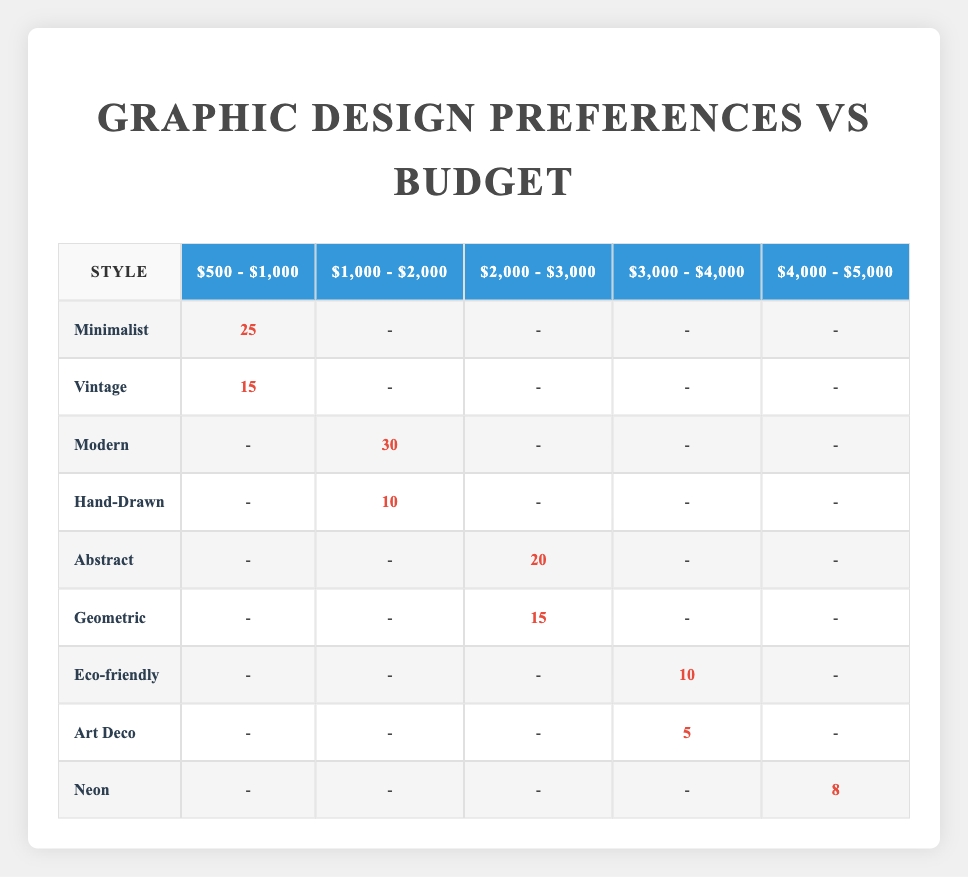What is the client count for the Minimalist style within the budget range of $500 - $1,000? The table lists the client count for the Minimalist style under the budget range of $500 - $1,000 as 25.
Answer: 25 How many clients prefer the Vintage style within the same budget range of $500 - $1,000? The table indicates that the client count for the Vintage style within the $500 - $1,000 budget range is 15.
Answer: 15 Which graphic design style has the highest number of clients within the budget range of $1,000 - $2,000? The Modern style has the highest client count of 30 within the $1,000 - $2,000 budget range.
Answer: Modern What is the total number of clients interested in budget ranges between $2,000 to $4,000? Summing the client counts from $2,000 - $3,000 (20 + 15) and $3,000 - $4,000 (10 + 5) gives a total of 50 clients.
Answer: 50 Is there any graphic design style that clients prefer in the budget range of $4,000 - $5,000? The only style listed in the budget range of $4,000 - $5,000 is Neon, with 8 clients preferring it, which confirms that there is a preference.
Answer: Yes What is the average client count for styles in the budget range of $1,000 - $2,000? There are two styles: Modern (30) and Hand-Drawn (10). The average is (30 + 10) / 2 = 20.
Answer: 20 Which two styles have the lowest client counts and how many clients do they have? The lowest counts are for Art Deco (5 clients) and Eco-friendly (10 clients). Combining these gives a clear idea of less popular styles.
Answer: Art Deco: 5, Eco-friendly: 10 What is the difference in client counts between the Abstract and Geometric styles within their budget range? The Abstract style has 20 clients and the Geometric style has 15 clients. The difference is 20 - 15 = 5 clients.
Answer: 5 If a new client wants to choose a style from the budget range of $2,000 - $3,000, which style has the least number of clients? Within the $2,000 - $3,000 range, the Geometric style has 15 clients, while Abstract has 20. Thus, Geometric is the least preferred.
Answer: Geometric How many clients are interested in Hand-Drawn compared to those interested in Neon? Hand-Drawn has 10 clients and Neon has 8 clients. Comparing these numbers shows that Hand-Drawn is preferred by 2 more clients.
Answer: Hand-Drawn: 10, Neon: 8 